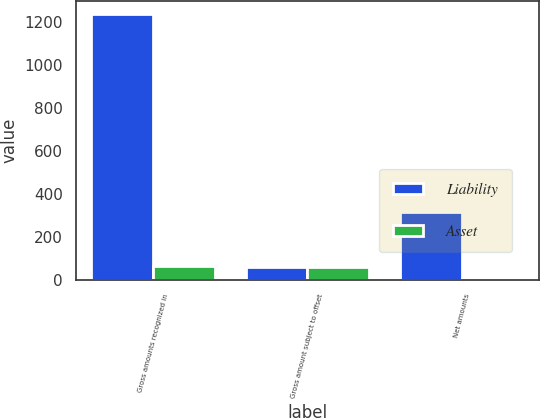<chart> <loc_0><loc_0><loc_500><loc_500><stacked_bar_chart><ecel><fcel>Gross amounts recognized in<fcel>Gross amount subject to offset<fcel>Net amounts<nl><fcel>Liability<fcel>1237<fcel>59<fcel>316<nl><fcel>Asset<fcel>63<fcel>59<fcel>4<nl></chart> 